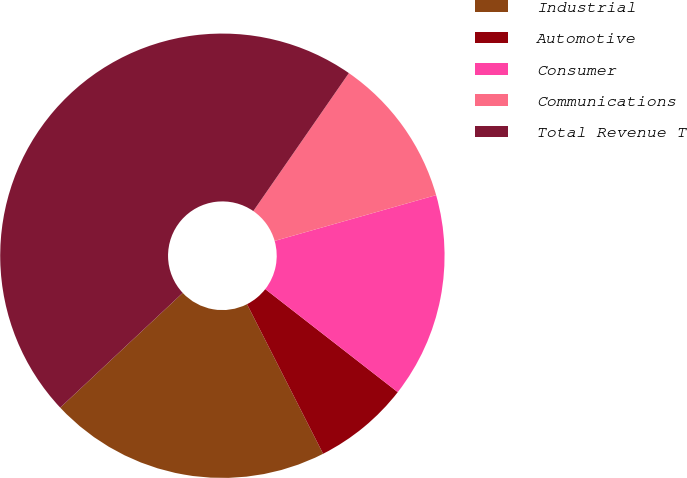<chart> <loc_0><loc_0><loc_500><loc_500><pie_chart><fcel>Industrial<fcel>Automotive<fcel>Consumer<fcel>Communications<fcel>Total Revenue T<nl><fcel>20.51%<fcel>6.99%<fcel>14.92%<fcel>10.96%<fcel>46.62%<nl></chart> 